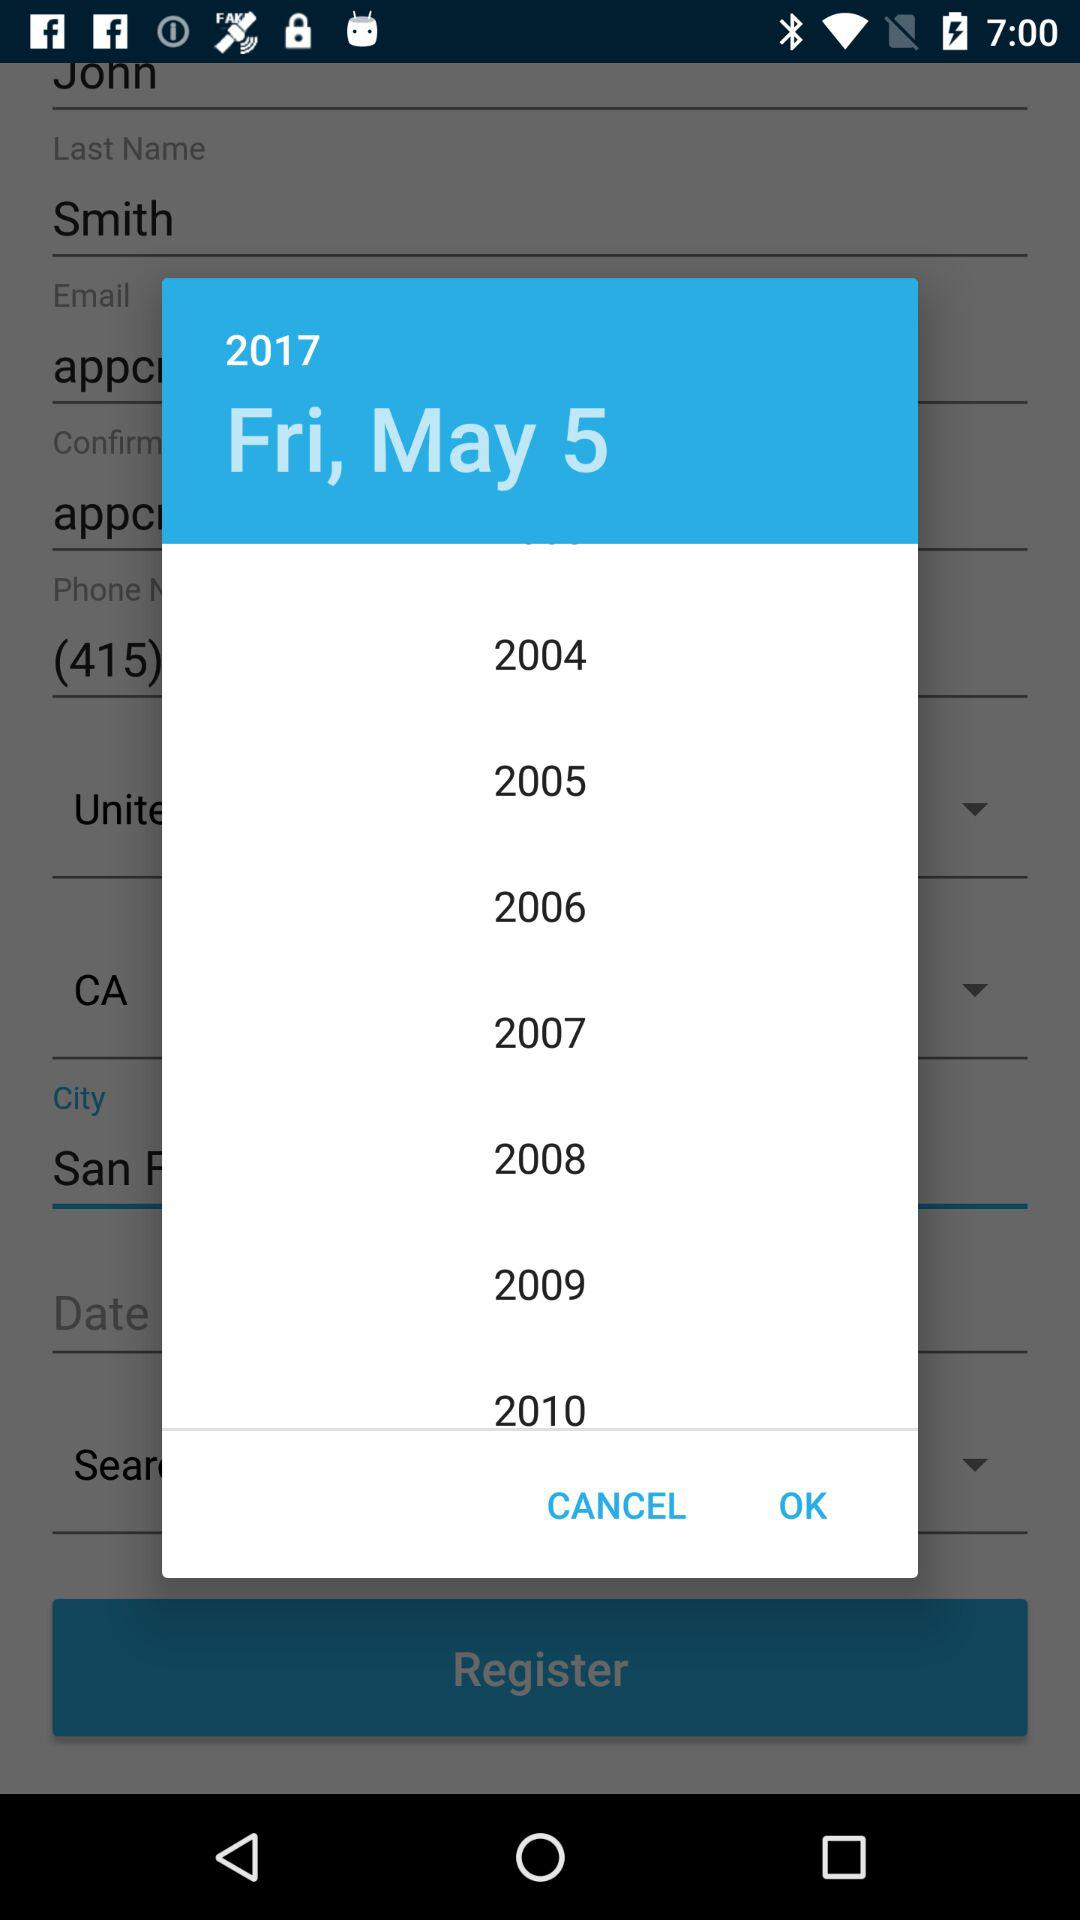What is the last name? The last name is Smith. 